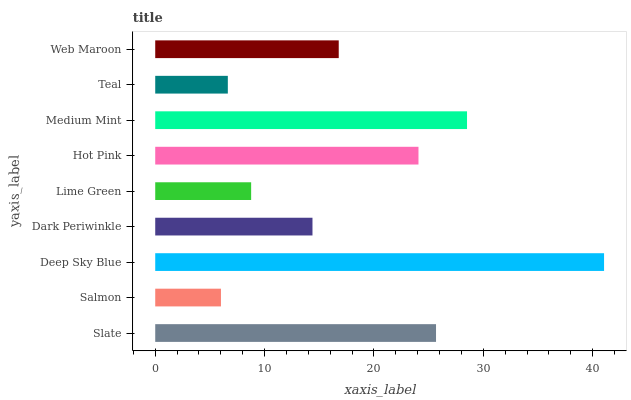Is Salmon the minimum?
Answer yes or no. Yes. Is Deep Sky Blue the maximum?
Answer yes or no. Yes. Is Deep Sky Blue the minimum?
Answer yes or no. No. Is Salmon the maximum?
Answer yes or no. No. Is Deep Sky Blue greater than Salmon?
Answer yes or no. Yes. Is Salmon less than Deep Sky Blue?
Answer yes or no. Yes. Is Salmon greater than Deep Sky Blue?
Answer yes or no. No. Is Deep Sky Blue less than Salmon?
Answer yes or no. No. Is Web Maroon the high median?
Answer yes or no. Yes. Is Web Maroon the low median?
Answer yes or no. Yes. Is Deep Sky Blue the high median?
Answer yes or no. No. Is Hot Pink the low median?
Answer yes or no. No. 